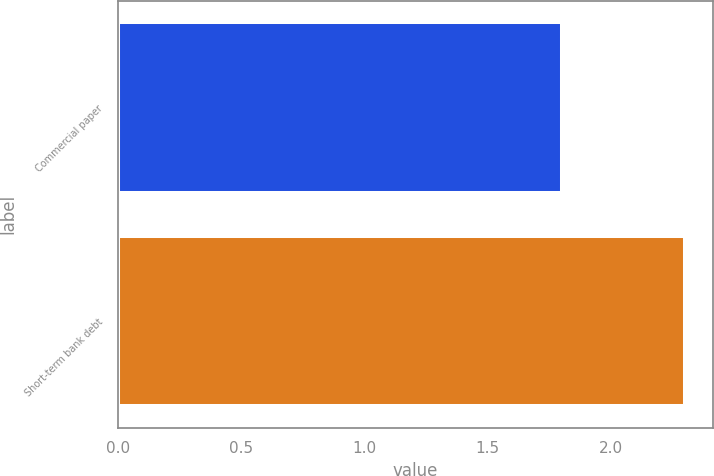<chart> <loc_0><loc_0><loc_500><loc_500><bar_chart><fcel>Commercial paper<fcel>Short-term bank debt<nl><fcel>1.8<fcel>2.3<nl></chart> 